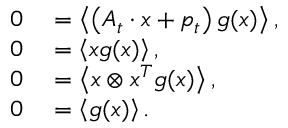<formula> <loc_0><loc_0><loc_500><loc_500>\begin{array} { r l } { 0 } & = \left \langle \left ( A _ { t } \cdot x + p _ { t } \right ) g ( x ) \right \rangle , } \\ { 0 } & = \left \langle x g ( x ) \right \rangle , } \\ { 0 } & = \left \langle x \otimes x ^ { T } g ( x ) \right \rangle , } \\ { 0 } & = \left \langle g ( x ) \right \rangle . } \end{array}</formula> 